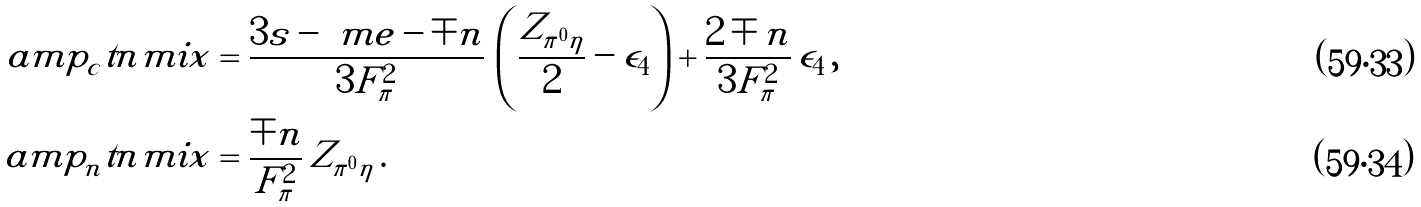Convert formula to latex. <formula><loc_0><loc_0><loc_500><loc_500>\ a m p _ { c } ^ { \ } t n { m i x } & = \frac { 3 s - \ m e - \mp n } { 3 F _ { \pi } ^ { 2 } } \, \left ( \frac { Z _ { \pi ^ { 0 } \eta } } { 2 } - \epsilon _ { 4 } \right ) + \frac { 2 \mp n } { 3 F _ { \pi } ^ { 2 } } \, \epsilon _ { 4 } \, , \\ \ a m p _ { n } ^ { \ } t n { m i x } & = \frac { \mp n } { F _ { \pi } ^ { 2 } } \, Z _ { \pi ^ { 0 } \eta } \, .</formula> 